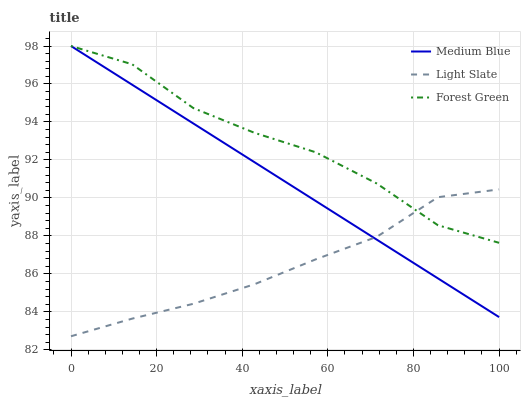Does Light Slate have the minimum area under the curve?
Answer yes or no. Yes. Does Forest Green have the maximum area under the curve?
Answer yes or no. Yes. Does Medium Blue have the minimum area under the curve?
Answer yes or no. No. Does Medium Blue have the maximum area under the curve?
Answer yes or no. No. Is Medium Blue the smoothest?
Answer yes or no. Yes. Is Forest Green the roughest?
Answer yes or no. Yes. Is Forest Green the smoothest?
Answer yes or no. No. Is Medium Blue the roughest?
Answer yes or no. No. Does Light Slate have the lowest value?
Answer yes or no. Yes. Does Medium Blue have the lowest value?
Answer yes or no. No. Does Medium Blue have the highest value?
Answer yes or no. Yes. Does Light Slate intersect Forest Green?
Answer yes or no. Yes. Is Light Slate less than Forest Green?
Answer yes or no. No. Is Light Slate greater than Forest Green?
Answer yes or no. No. 